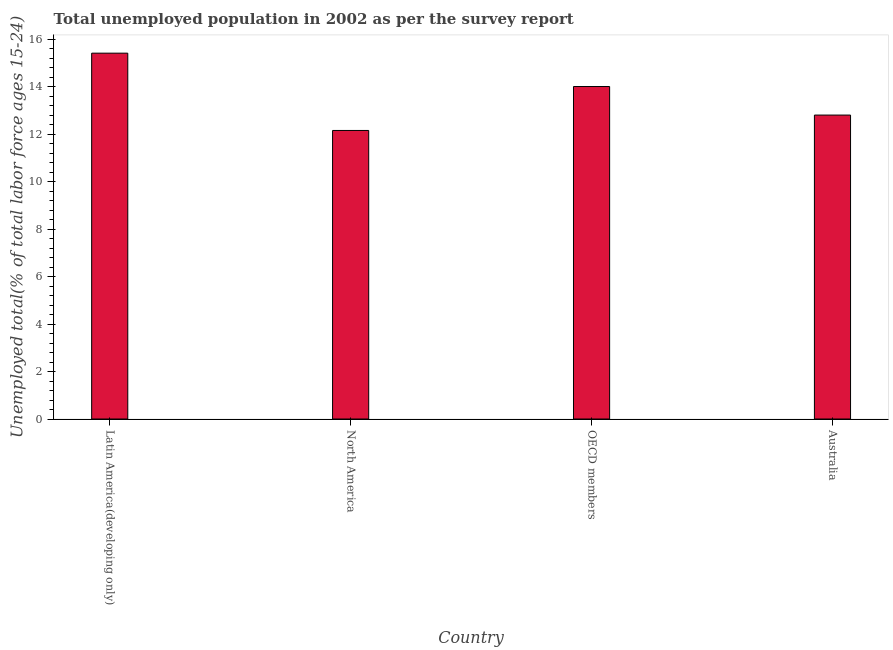Does the graph contain any zero values?
Ensure brevity in your answer.  No. What is the title of the graph?
Your response must be concise. Total unemployed population in 2002 as per the survey report. What is the label or title of the Y-axis?
Your answer should be very brief. Unemployed total(% of total labor force ages 15-24). What is the unemployed youth in Latin America(developing only)?
Ensure brevity in your answer.  15.41. Across all countries, what is the maximum unemployed youth?
Provide a succinct answer. 15.41. Across all countries, what is the minimum unemployed youth?
Offer a very short reply. 12.15. In which country was the unemployed youth maximum?
Offer a very short reply. Latin America(developing only). In which country was the unemployed youth minimum?
Offer a terse response. North America. What is the sum of the unemployed youth?
Give a very brief answer. 54.36. What is the difference between the unemployed youth in Latin America(developing only) and North America?
Offer a very short reply. 3.25. What is the average unemployed youth per country?
Keep it short and to the point. 13.59. What is the median unemployed youth?
Ensure brevity in your answer.  13.4. In how many countries, is the unemployed youth greater than 2.4 %?
Make the answer very short. 4. What is the ratio of the unemployed youth in Latin America(developing only) to that in North America?
Provide a short and direct response. 1.27. Is the unemployed youth in North America less than that in OECD members?
Offer a terse response. Yes. Is the difference between the unemployed youth in Australia and North America greater than the difference between any two countries?
Keep it short and to the point. No. What is the difference between the highest and the second highest unemployed youth?
Provide a succinct answer. 1.4. In how many countries, is the unemployed youth greater than the average unemployed youth taken over all countries?
Offer a terse response. 2. What is the difference between two consecutive major ticks on the Y-axis?
Offer a very short reply. 2. Are the values on the major ticks of Y-axis written in scientific E-notation?
Your answer should be very brief. No. What is the Unemployed total(% of total labor force ages 15-24) of Latin America(developing only)?
Your answer should be very brief. 15.41. What is the Unemployed total(% of total labor force ages 15-24) of North America?
Provide a short and direct response. 12.15. What is the Unemployed total(% of total labor force ages 15-24) of OECD members?
Ensure brevity in your answer.  14. What is the Unemployed total(% of total labor force ages 15-24) in Australia?
Your answer should be compact. 12.8. What is the difference between the Unemployed total(% of total labor force ages 15-24) in Latin America(developing only) and North America?
Provide a succinct answer. 3.25. What is the difference between the Unemployed total(% of total labor force ages 15-24) in Latin America(developing only) and OECD members?
Ensure brevity in your answer.  1.4. What is the difference between the Unemployed total(% of total labor force ages 15-24) in Latin America(developing only) and Australia?
Offer a very short reply. 2.61. What is the difference between the Unemployed total(% of total labor force ages 15-24) in North America and OECD members?
Your answer should be very brief. -1.85. What is the difference between the Unemployed total(% of total labor force ages 15-24) in North America and Australia?
Ensure brevity in your answer.  -0.65. What is the difference between the Unemployed total(% of total labor force ages 15-24) in OECD members and Australia?
Provide a succinct answer. 1.2. What is the ratio of the Unemployed total(% of total labor force ages 15-24) in Latin America(developing only) to that in North America?
Ensure brevity in your answer.  1.27. What is the ratio of the Unemployed total(% of total labor force ages 15-24) in Latin America(developing only) to that in OECD members?
Your response must be concise. 1.1. What is the ratio of the Unemployed total(% of total labor force ages 15-24) in Latin America(developing only) to that in Australia?
Provide a short and direct response. 1.2. What is the ratio of the Unemployed total(% of total labor force ages 15-24) in North America to that in OECD members?
Keep it short and to the point. 0.87. What is the ratio of the Unemployed total(% of total labor force ages 15-24) in North America to that in Australia?
Offer a terse response. 0.95. What is the ratio of the Unemployed total(% of total labor force ages 15-24) in OECD members to that in Australia?
Offer a very short reply. 1.09. 